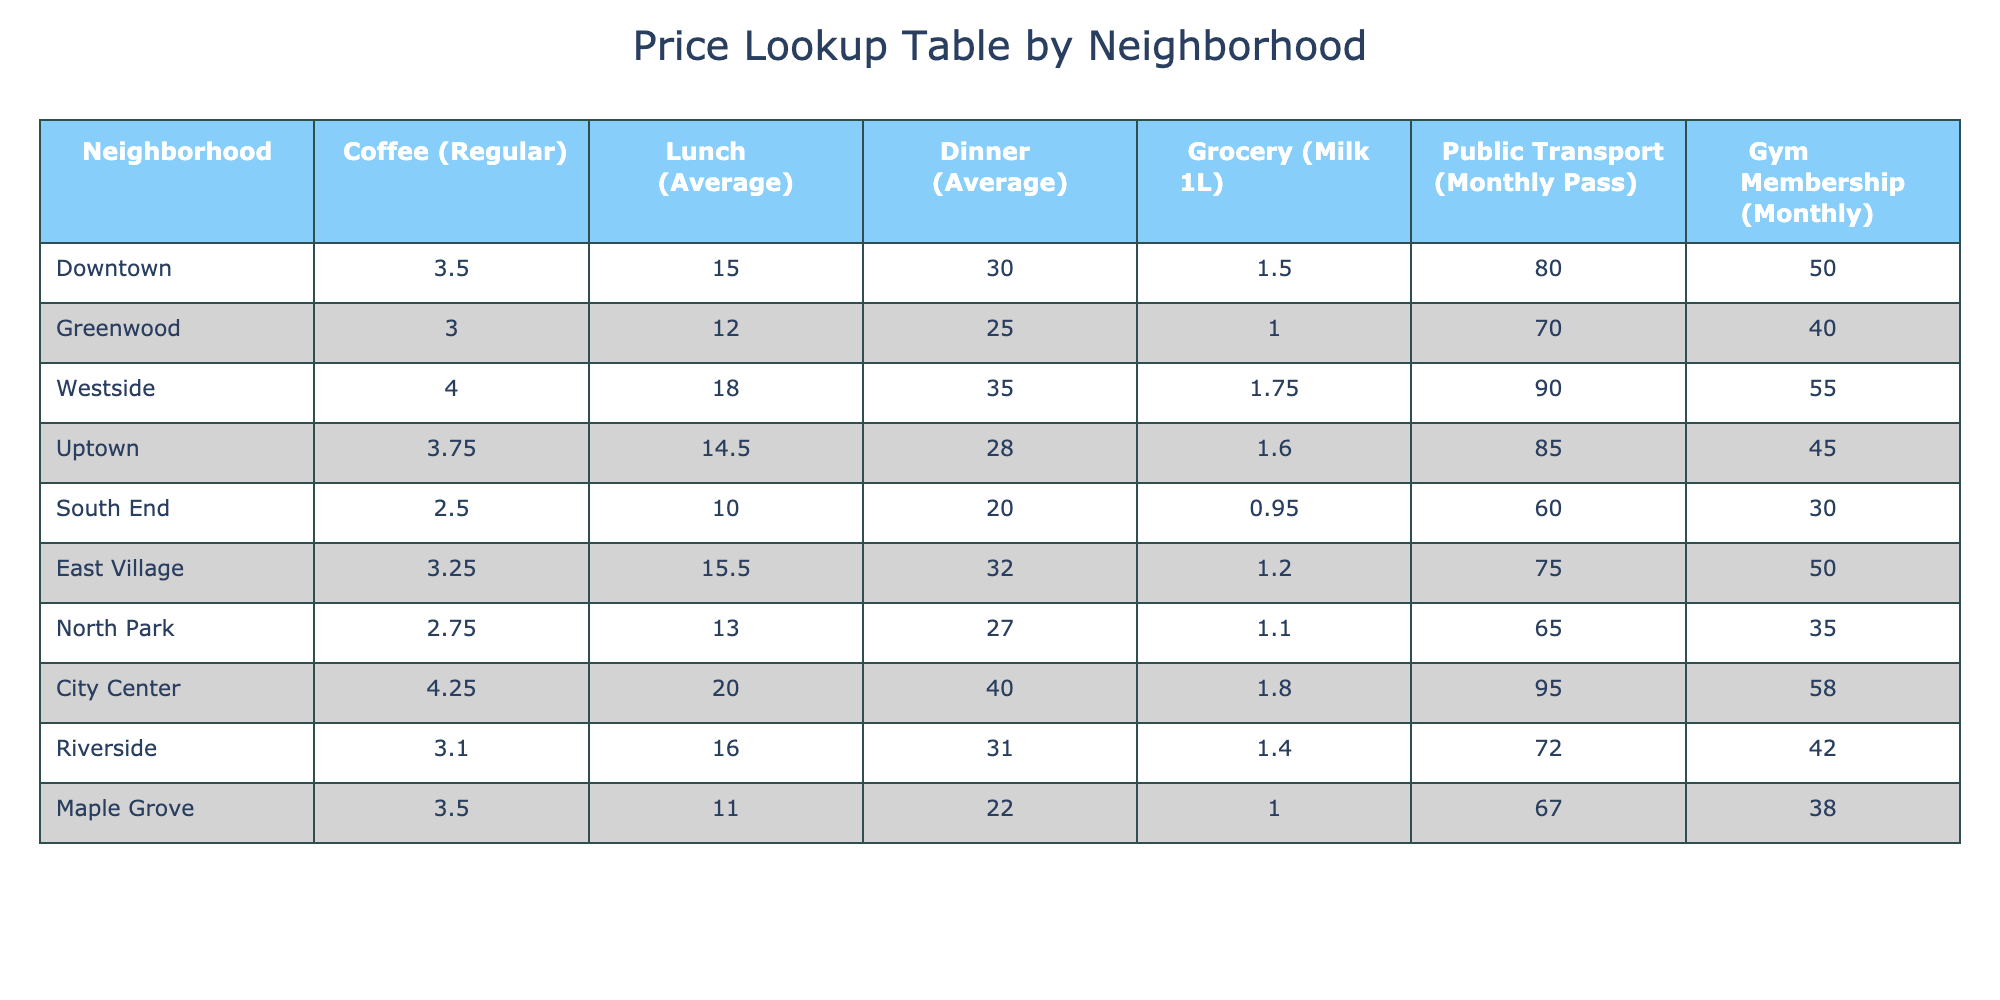What is the average cost of a coffee in the City Center? The price of a regular coffee in the City Center is listed as 4.25. Since this is a retrieval question, we simply refer to the table to find the value directly.
Answer: 4.25 Which neighborhood has the lowest average cost for lunch? Looking at the average lunch prices across all neighborhoods, South End has the lowest average cost at 10.00. This is found by comparing each neighborhood’s lunch price.
Answer: 10.00 What is the total cost for a monthly pass for public transport in Downtown and Greenwood combined? The cost of a monthly public transport pass in Downtown is 80.00, and in Greenwood, it is 70.00. We sum these two values: 80.00 + 70.00 = 150.00.
Answer: 150.00 Is the dinner price in East Village higher than in Uptown? The dinner price in East Village is 32.00 and in Uptown it is 28.00. Since 32.00 is greater than 28.00, the statement is true.
Answer: Yes What is the average price of groceries (milk 1L) across all neighborhoods? To find the average price, we sum all the prices of 1L milk from each neighborhood: (1.50 + 1.00 + 1.75 + 1.60 + 0.95 + 1.20 + 1.10 + 1.80 + 1.40 + 1.00) = 12.10. There are 10 neighborhoods, so the average is 12.10 / 10 = 1.21.
Answer: 1.21 Which neighborhood provides the most affordable gym membership? Referring to the gym membership prices, we see that South End has the lowest cost at 30.00. This is done through a simple comparison of prices.
Answer: 30.00 How much more does dinner cost in Westside compared to South End? The dinner price in Westside is 35.00, while in South End it is 20.00. To determine the difference: 35.00 - 20.00 = 15.00.
Answer: 15.00 Is the price of a regular coffee in North Park less than that in the East Village? The price of coffee in North Park is 2.75, while in East Village, it is 3.25. Since 2.75 is less than 3.25, this statement is true.
Answer: Yes What is the maximum price for lunch among all neighborhoods? By reviewing the lunch prices listed, City Center has the highest lunch price at 20.00. This is verified by comparing all entries for lunch prices.
Answer: 20.00 